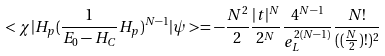Convert formula to latex. <formula><loc_0><loc_0><loc_500><loc_500>< \chi | H _ { p } ( \frac { 1 } { E _ { 0 } - H _ { C } } H _ { p } ) ^ { N - 1 } | \psi > = - \frac { N ^ { 2 } } { 2 } \frac { | t | ^ { N } } { 2 ^ { N } } \frac { 4 ^ { N - 1 } } { e _ { L } ^ { 2 ( N - 1 ) } } \frac { N ! } { ( ( \frac { N } { 2 } ) ! ) ^ { 2 } }</formula> 